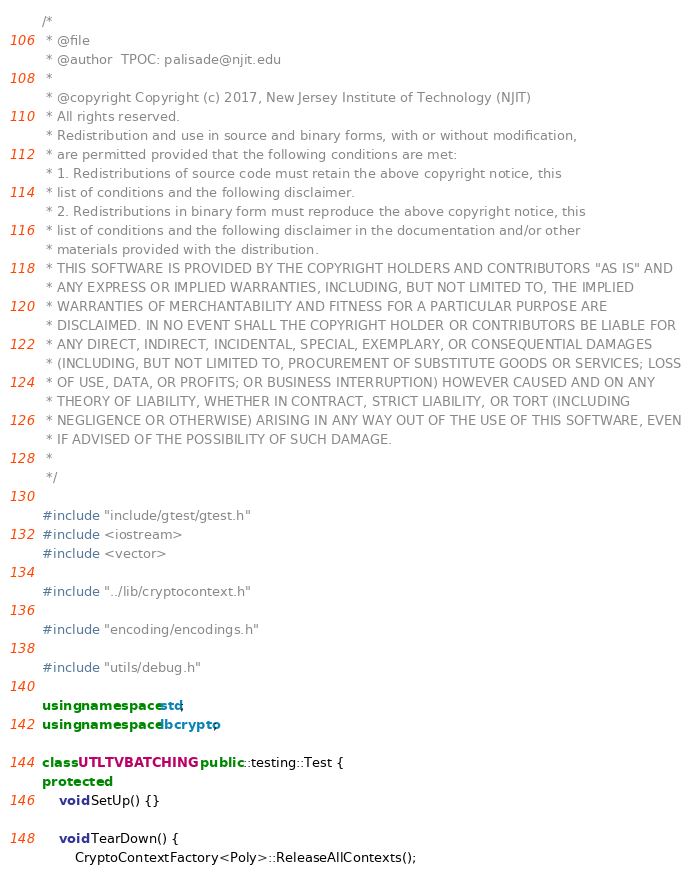<code> <loc_0><loc_0><loc_500><loc_500><_C++_>/*
 * @file 
 * @author  TPOC: palisade@njit.edu
 *
 * @copyright Copyright (c) 2017, New Jersey Institute of Technology (NJIT)
 * All rights reserved.
 * Redistribution and use in source and binary forms, with or without modification,
 * are permitted provided that the following conditions are met:
 * 1. Redistributions of source code must retain the above copyright notice, this
 * list of conditions and the following disclaimer.
 * 2. Redistributions in binary form must reproduce the above copyright notice, this
 * list of conditions and the following disclaimer in the documentation and/or other
 * materials provided with the distribution.
 * THIS SOFTWARE IS PROVIDED BY THE COPYRIGHT HOLDERS AND CONTRIBUTORS "AS IS" AND
 * ANY EXPRESS OR IMPLIED WARRANTIES, INCLUDING, BUT NOT LIMITED TO, THE IMPLIED
 * WARRANTIES OF MERCHANTABILITY AND FITNESS FOR A PARTICULAR PURPOSE ARE
 * DISCLAIMED. IN NO EVENT SHALL THE COPYRIGHT HOLDER OR CONTRIBUTORS BE LIABLE FOR
 * ANY DIRECT, INDIRECT, INCIDENTAL, SPECIAL, EXEMPLARY, OR CONSEQUENTIAL DAMAGES
 * (INCLUDING, BUT NOT LIMITED TO, PROCUREMENT OF SUBSTITUTE GOODS OR SERVICES; LOSS
 * OF USE, DATA, OR PROFITS; OR BUSINESS INTERRUPTION) HOWEVER CAUSED AND ON ANY
 * THEORY OF LIABILITY, WHETHER IN CONTRACT, STRICT LIABILITY, OR TORT (INCLUDING
 * NEGLIGENCE OR OTHERWISE) ARISING IN ANY WAY OUT OF THE USE OF THIS SOFTWARE, EVEN
 * IF ADVISED OF THE POSSIBILITY OF SUCH DAMAGE.
 *
 */

#include "include/gtest/gtest.h"
#include <iostream>
#include <vector>

#include "../lib/cryptocontext.h"

#include "encoding/encodings.h"

#include "utils/debug.h"

using namespace std;
using namespace lbcrypto;

class UTLTVBATCHING : public ::testing::Test {
protected:
	void SetUp() {}

	void TearDown() {
		CryptoContextFactory<Poly>::ReleaseAllContexts();</code> 